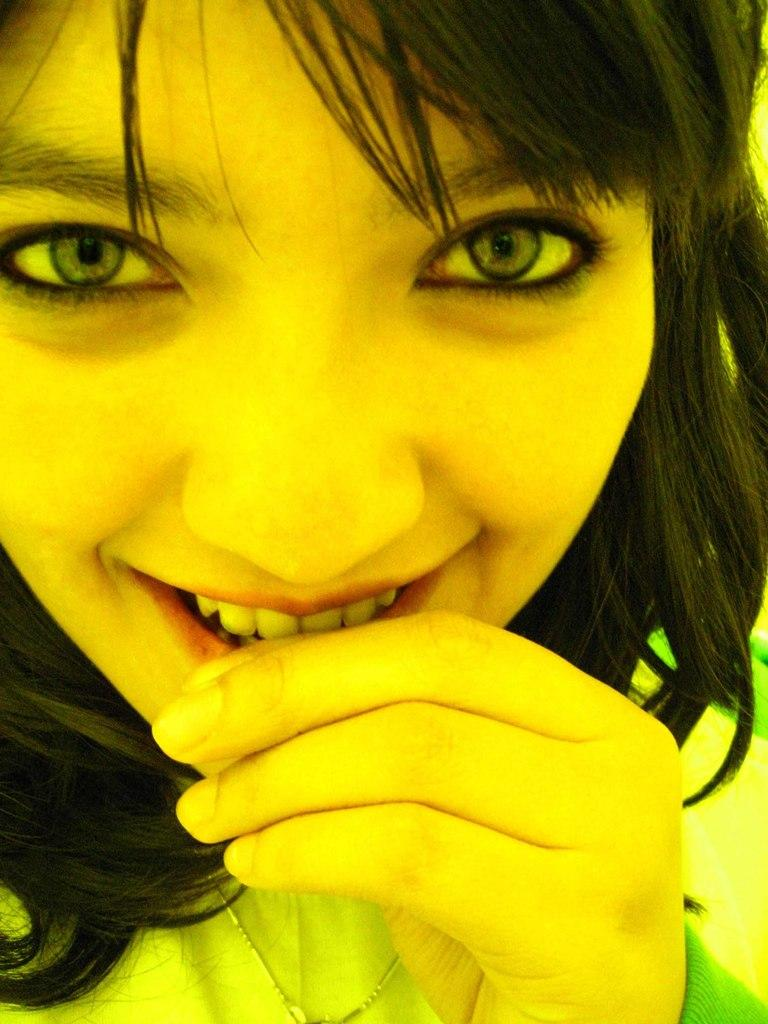Who is present in the image? There is a woman in the image. What type of straw is the woman using to calculate the stars in the image? There is no straw or stars present in the image, and the woman is not using a calculator. 